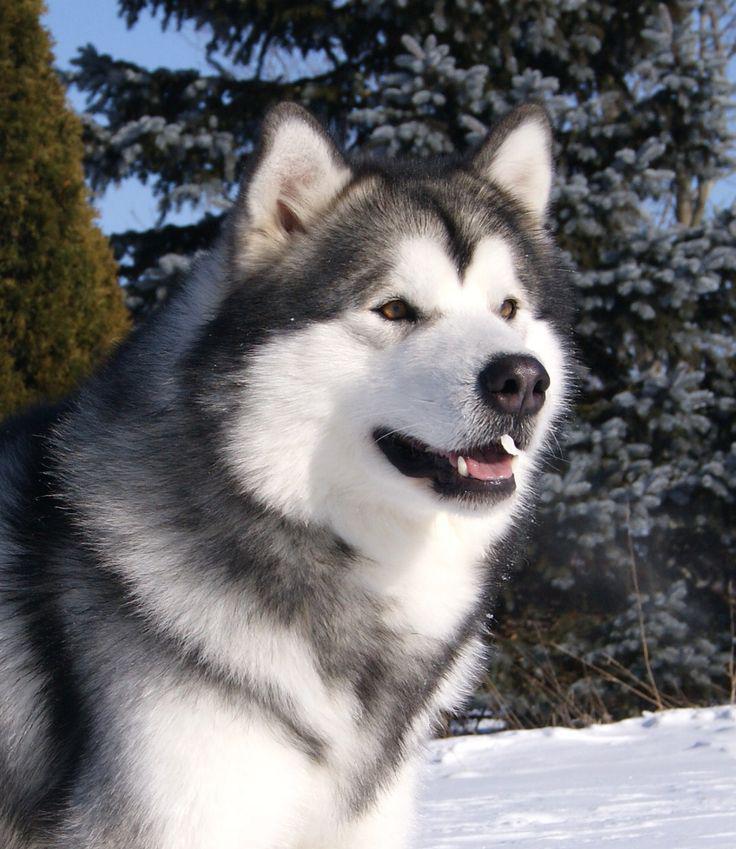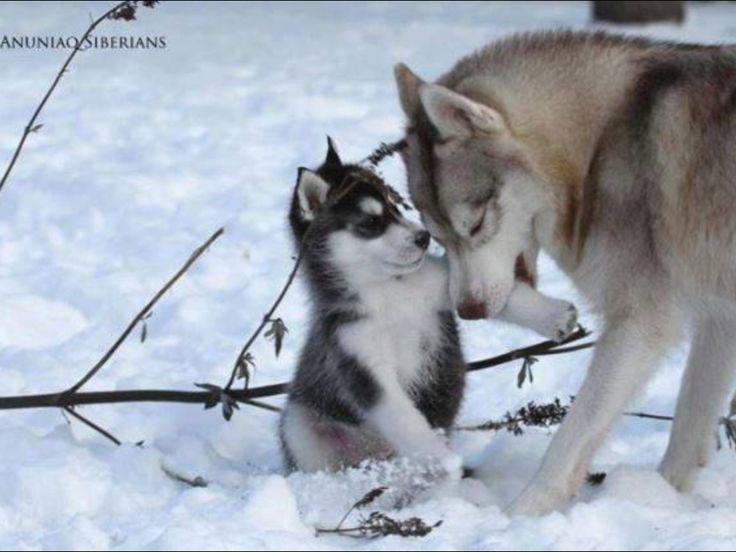The first image is the image on the left, the second image is the image on the right. Examine the images to the left and right. Is the description "The right image contains at least two dogs." accurate? Answer yes or no. Yes. The first image is the image on the left, the second image is the image on the right. Assess this claim about the two images: "There are a minimum of two dogs present in the images". Correct or not? Answer yes or no. Yes. 